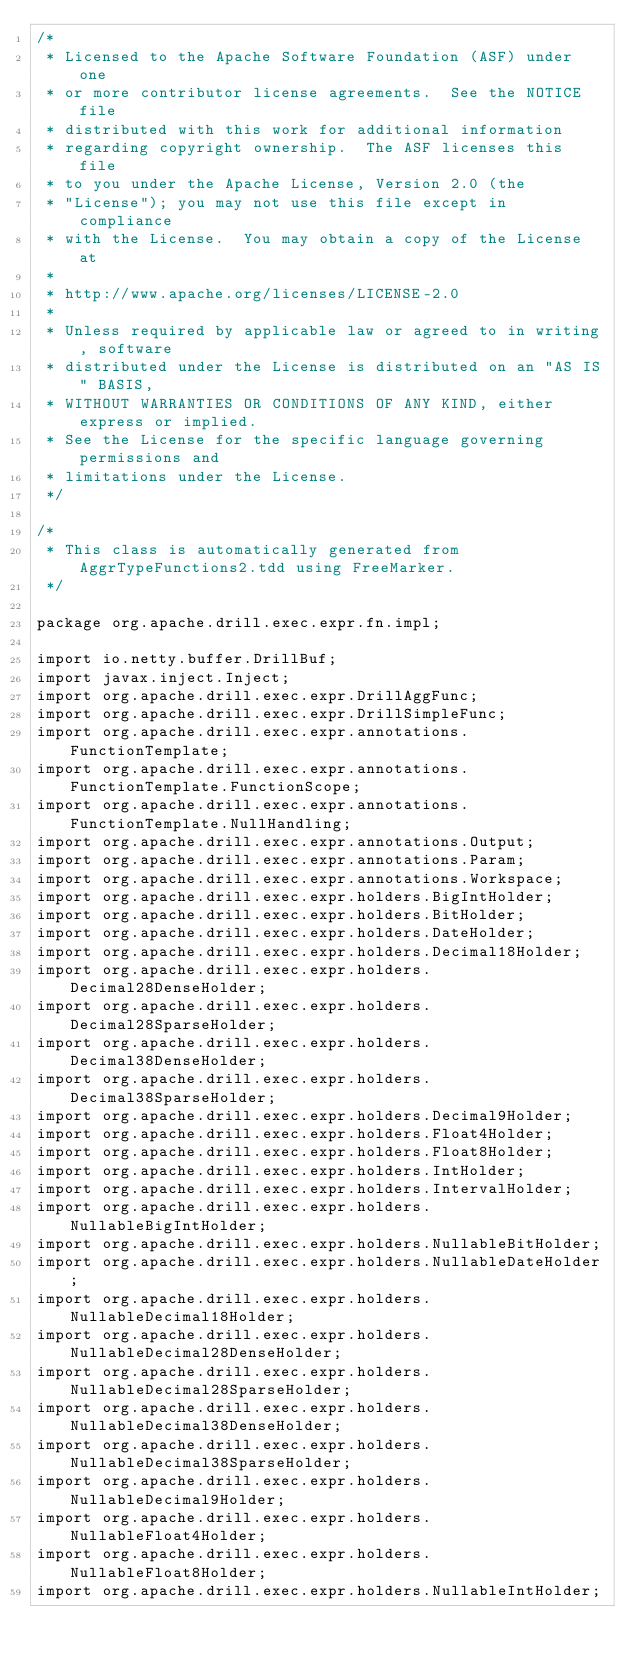Convert code to text. <code><loc_0><loc_0><loc_500><loc_500><_Java_>/*
 * Licensed to the Apache Software Foundation (ASF) under one
 * or more contributor license agreements.  See the NOTICE file
 * distributed with this work for additional information
 * regarding copyright ownership.  The ASF licenses this file
 * to you under the Apache License, Version 2.0 (the
 * "License"); you may not use this file except in compliance
 * with the License.  You may obtain a copy of the License at
 *
 * http://www.apache.org/licenses/LICENSE-2.0
 *
 * Unless required by applicable law or agreed to in writing, software
 * distributed under the License is distributed on an "AS IS" BASIS,
 * WITHOUT WARRANTIES OR CONDITIONS OF ANY KIND, either express or implied.
 * See the License for the specific language governing permissions and
 * limitations under the License.
 */

/*
 * This class is automatically generated from AggrTypeFunctions2.tdd using FreeMarker.
 */

package org.apache.drill.exec.expr.fn.impl;

import io.netty.buffer.DrillBuf;
import javax.inject.Inject;
import org.apache.drill.exec.expr.DrillAggFunc;
import org.apache.drill.exec.expr.DrillSimpleFunc;
import org.apache.drill.exec.expr.annotations.FunctionTemplate;
import org.apache.drill.exec.expr.annotations.FunctionTemplate.FunctionScope;
import org.apache.drill.exec.expr.annotations.FunctionTemplate.NullHandling;
import org.apache.drill.exec.expr.annotations.Output;
import org.apache.drill.exec.expr.annotations.Param;
import org.apache.drill.exec.expr.annotations.Workspace;
import org.apache.drill.exec.expr.holders.BigIntHolder;
import org.apache.drill.exec.expr.holders.BitHolder;
import org.apache.drill.exec.expr.holders.DateHolder;
import org.apache.drill.exec.expr.holders.Decimal18Holder;
import org.apache.drill.exec.expr.holders.Decimal28DenseHolder;
import org.apache.drill.exec.expr.holders.Decimal28SparseHolder;
import org.apache.drill.exec.expr.holders.Decimal38DenseHolder;
import org.apache.drill.exec.expr.holders.Decimal38SparseHolder;
import org.apache.drill.exec.expr.holders.Decimal9Holder;
import org.apache.drill.exec.expr.holders.Float4Holder;
import org.apache.drill.exec.expr.holders.Float8Holder;
import org.apache.drill.exec.expr.holders.IntHolder;
import org.apache.drill.exec.expr.holders.IntervalHolder;
import org.apache.drill.exec.expr.holders.NullableBigIntHolder;
import org.apache.drill.exec.expr.holders.NullableBitHolder;
import org.apache.drill.exec.expr.holders.NullableDateHolder;
import org.apache.drill.exec.expr.holders.NullableDecimal18Holder;
import org.apache.drill.exec.expr.holders.NullableDecimal28DenseHolder;
import org.apache.drill.exec.expr.holders.NullableDecimal28SparseHolder;
import org.apache.drill.exec.expr.holders.NullableDecimal38DenseHolder;
import org.apache.drill.exec.expr.holders.NullableDecimal38SparseHolder;
import org.apache.drill.exec.expr.holders.NullableDecimal9Holder;
import org.apache.drill.exec.expr.holders.NullableFloat4Holder;
import org.apache.drill.exec.expr.holders.NullableFloat8Holder;
import org.apache.drill.exec.expr.holders.NullableIntHolder;</code> 